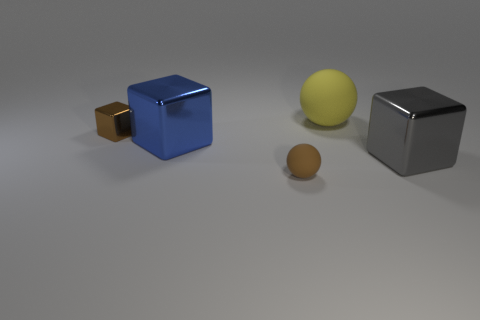Can you describe the lighting and shadows in the image? Certainly! The overall lighting in the image casts diffuse shadows on the ground, with a gentle gradient suggesting an ambient light source overhead. Each object projects a soft-edged shadow that aligns with the perspective, indicating the light source is to the top-left of the scene. 